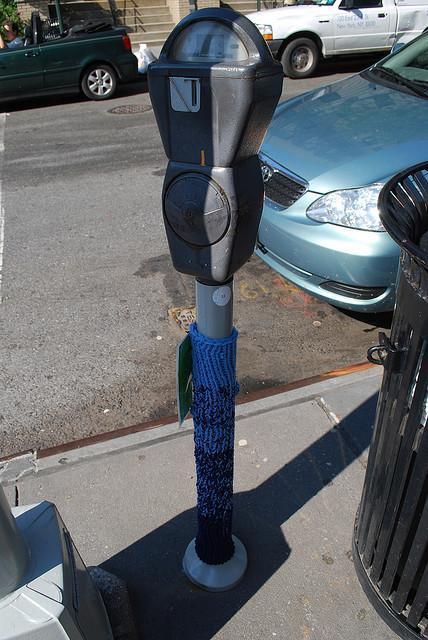How many cars are visible?
Give a very brief answer. 3. How many zebras are there?
Give a very brief answer. 0. 